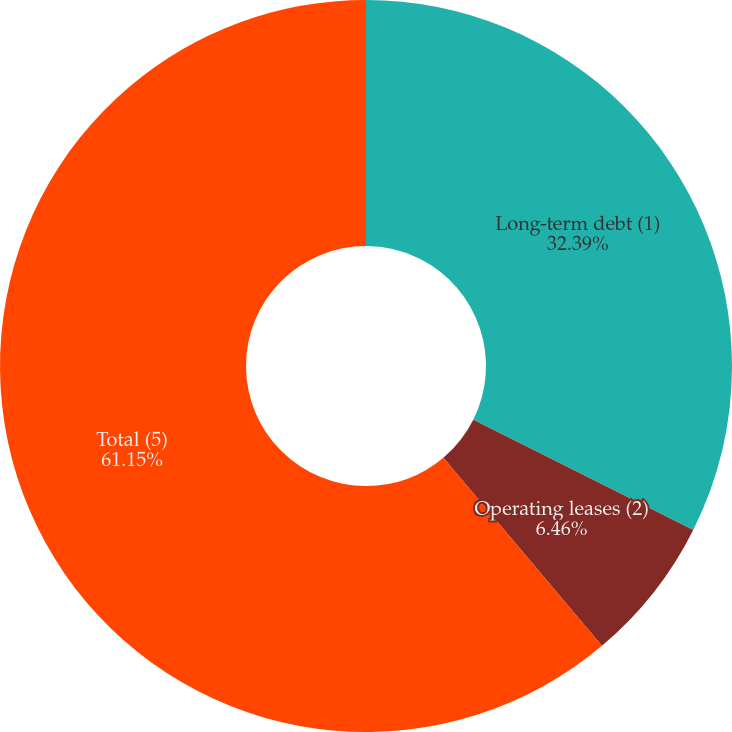Convert chart to OTSL. <chart><loc_0><loc_0><loc_500><loc_500><pie_chart><fcel>Long-term debt (1)<fcel>Operating leases (2)<fcel>Total (5)<nl><fcel>32.39%<fcel>6.46%<fcel>61.15%<nl></chart> 